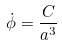<formula> <loc_0><loc_0><loc_500><loc_500>\dot { \phi } = \frac { C } { a ^ { 3 } }</formula> 